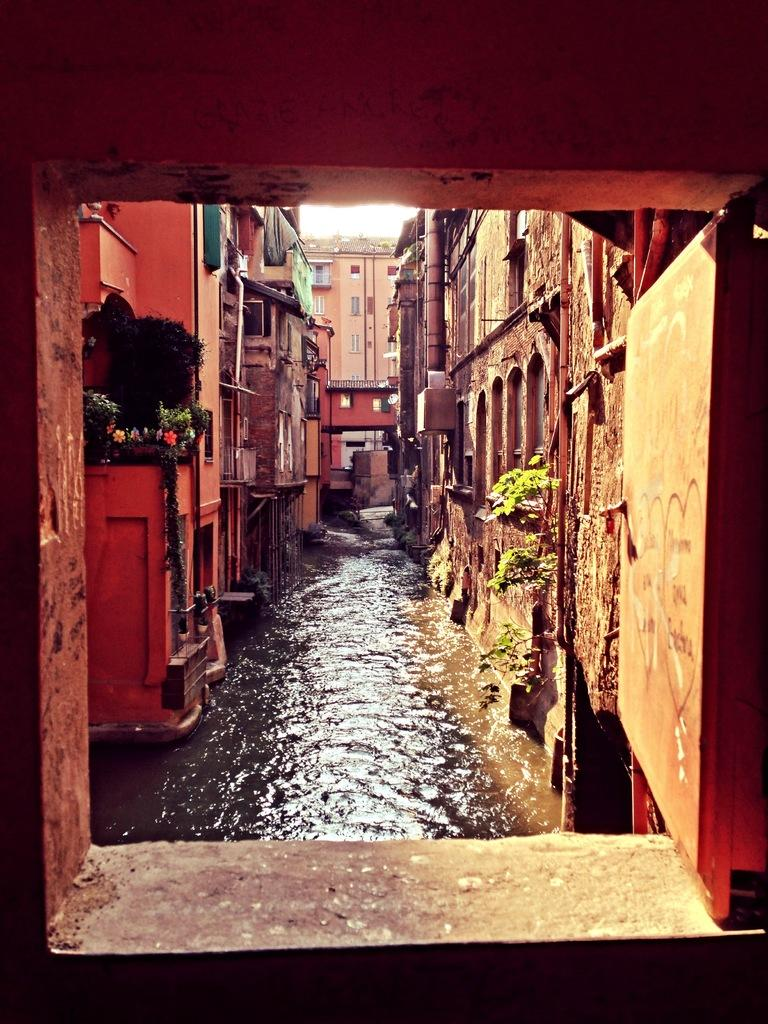What is flowing in the image? There is sewage water flowing in the image. Where is the sewage water located in relation to the houses? The sewage water is behind houses. What structures are present around the sewage water? There are buildings around the sewage water. What type of trip can be seen being taken by the patch in the image? There is no patch present in the image, so it is not possible to determine what type of trip it might be taking. 